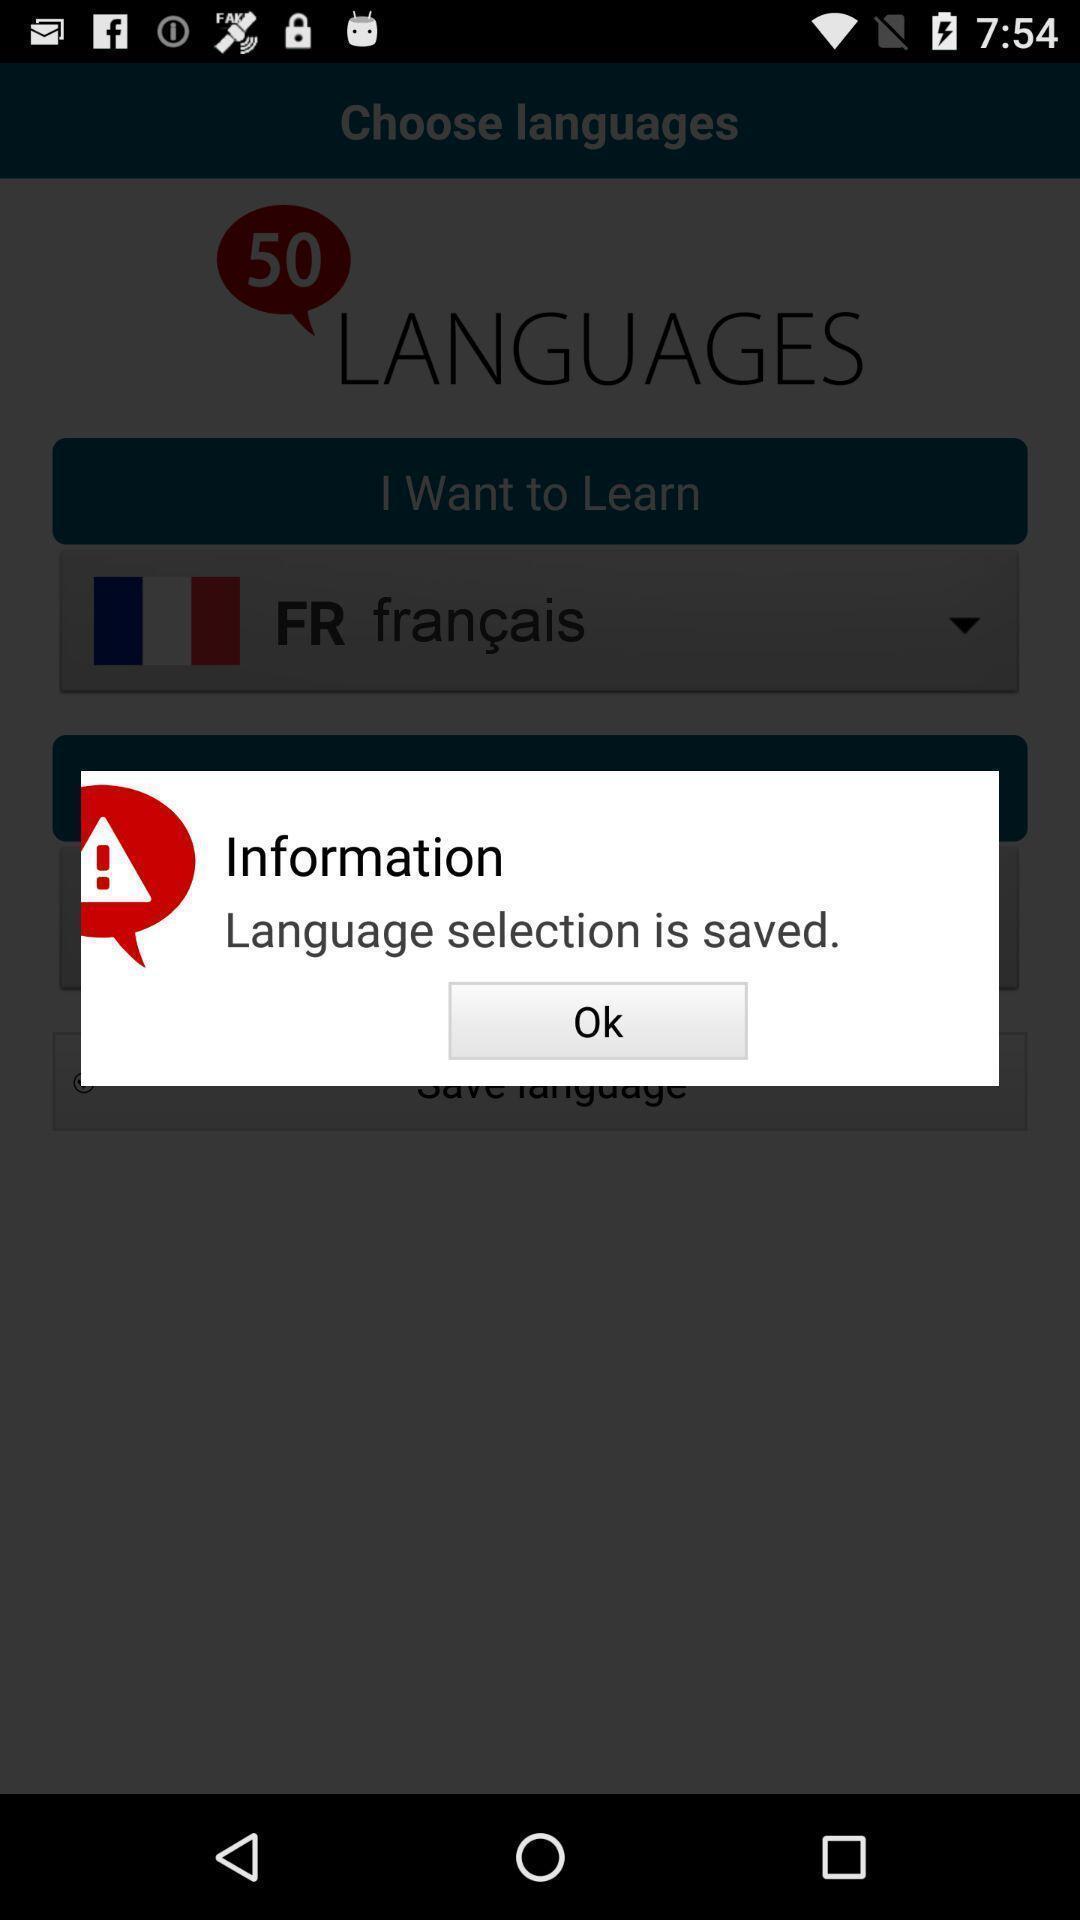Provide a textual representation of this image. Pop-up displaying language saved in a learning app. 